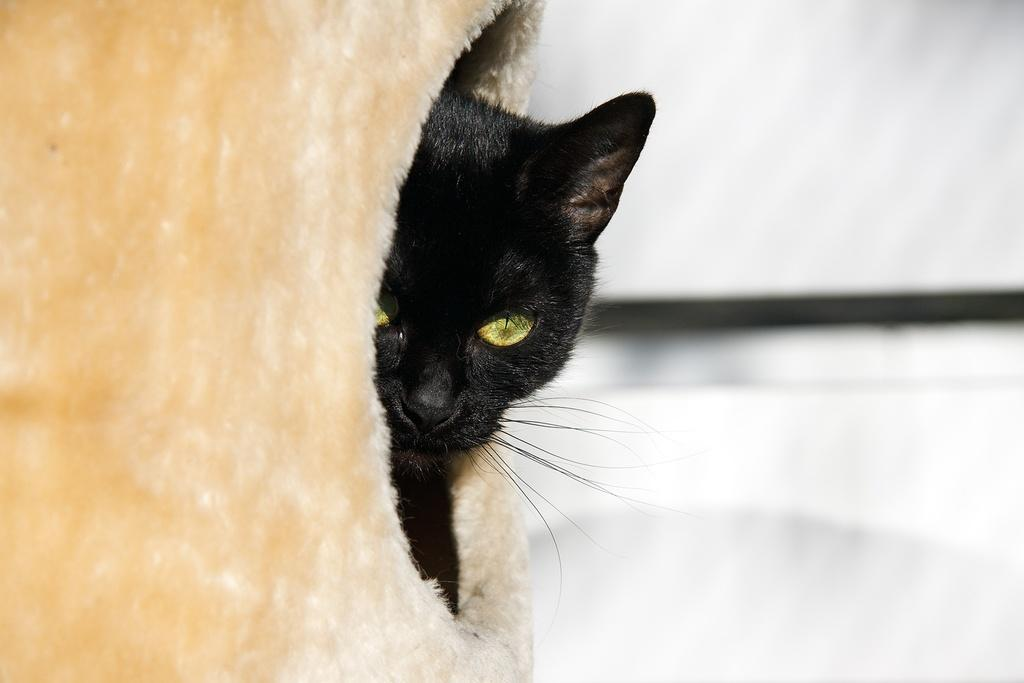What animal is the main subject of the image? There is a black cat in the middle of the image. Can you describe the background of the image? The background of the image is blurred. What type of liquid is being used to treat the disease in the image? There is no mention of a disease or liquid in the image; it features a black cat with a blurred background. 